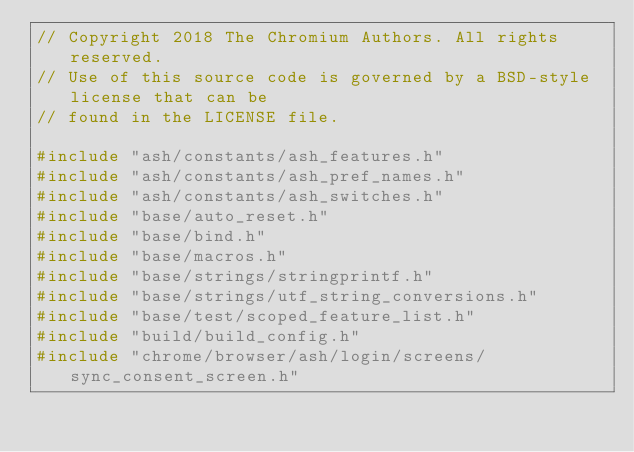Convert code to text. <code><loc_0><loc_0><loc_500><loc_500><_C++_>// Copyright 2018 The Chromium Authors. All rights reserved.
// Use of this source code is governed by a BSD-style license that can be
// found in the LICENSE file.

#include "ash/constants/ash_features.h"
#include "ash/constants/ash_pref_names.h"
#include "ash/constants/ash_switches.h"
#include "base/auto_reset.h"
#include "base/bind.h"
#include "base/macros.h"
#include "base/strings/stringprintf.h"
#include "base/strings/utf_string_conversions.h"
#include "base/test/scoped_feature_list.h"
#include "build/build_config.h"
#include "chrome/browser/ash/login/screens/sync_consent_screen.h"</code> 